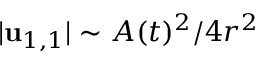<formula> <loc_0><loc_0><loc_500><loc_500>| u _ { 1 , 1 } | \sim A ( t ) ^ { 2 } / 4 r ^ { 2 }</formula> 